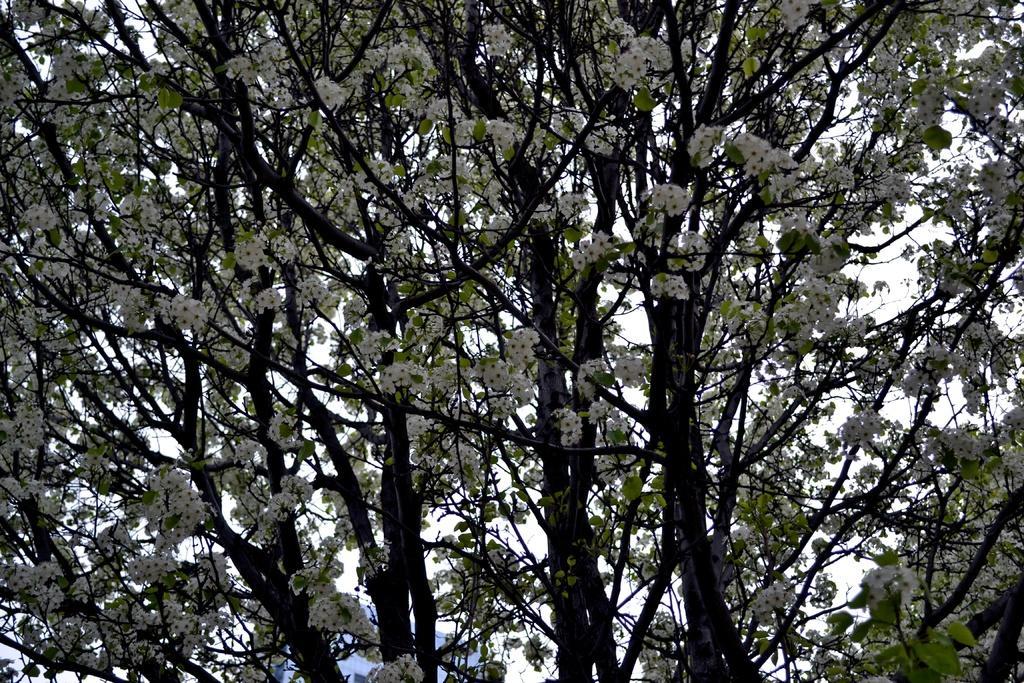Could you give a brief overview of what you see in this image? In this picture we can see trees with flowers and in the background we can see the sky. 